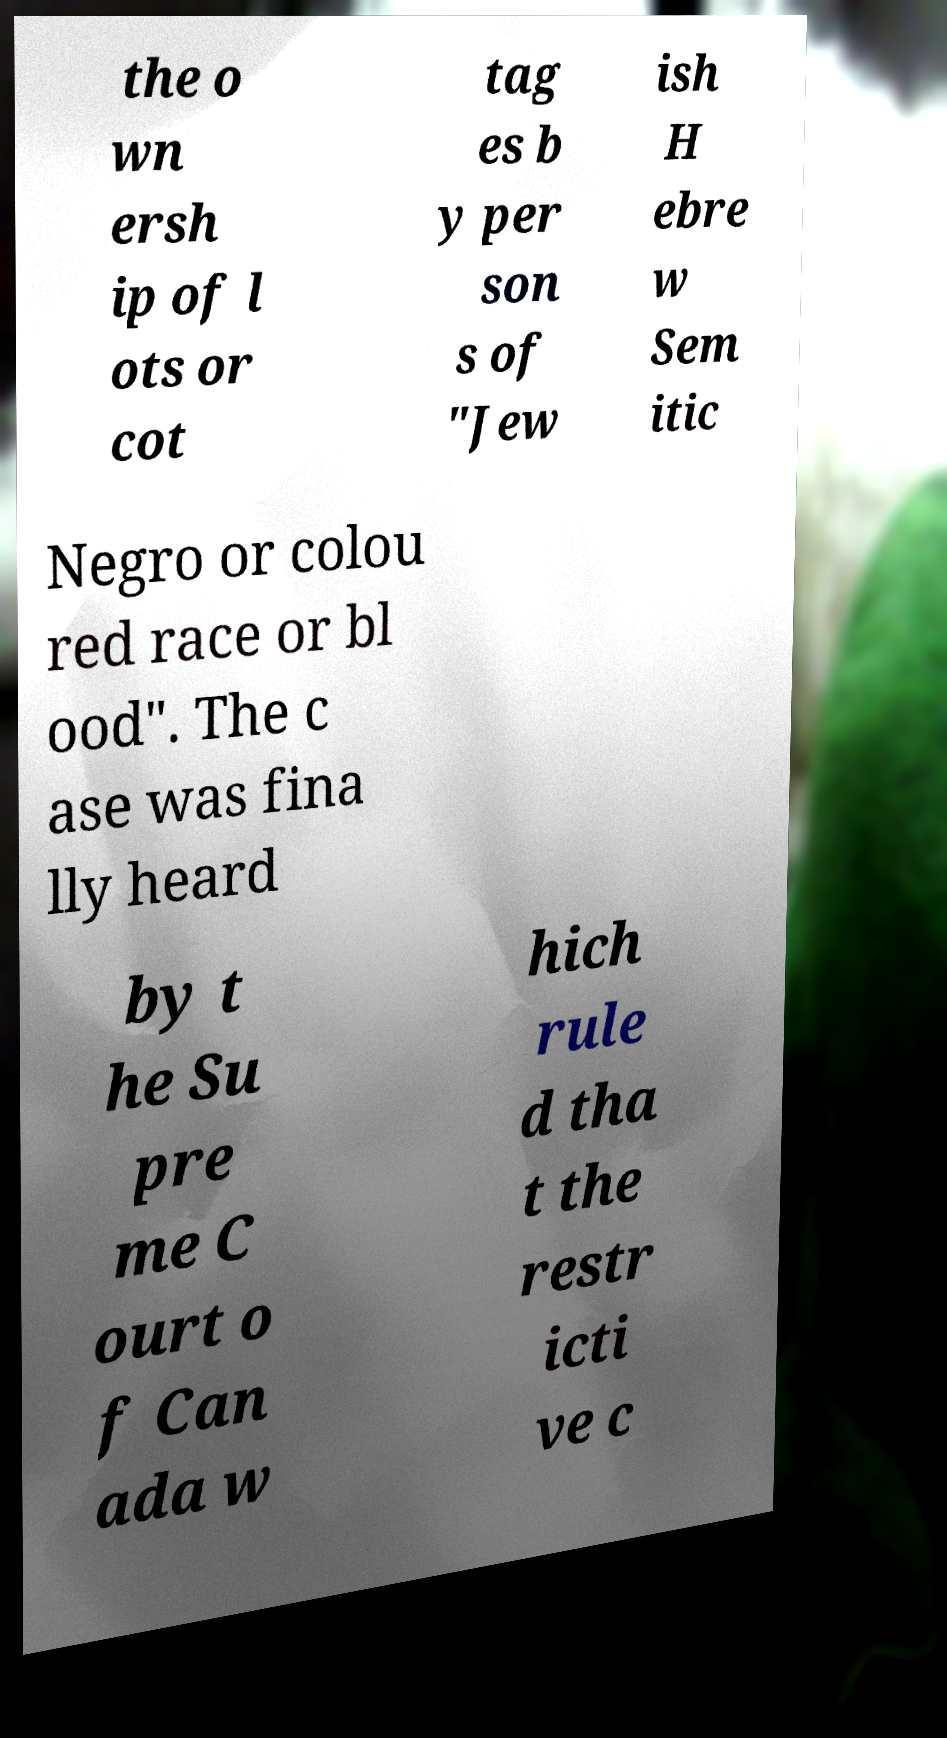Can you read and provide the text displayed in the image?This photo seems to have some interesting text. Can you extract and type it out for me? the o wn ersh ip of l ots or cot tag es b y per son s of "Jew ish H ebre w Sem itic Negro or colou red race or bl ood". The c ase was fina lly heard by t he Su pre me C ourt o f Can ada w hich rule d tha t the restr icti ve c 